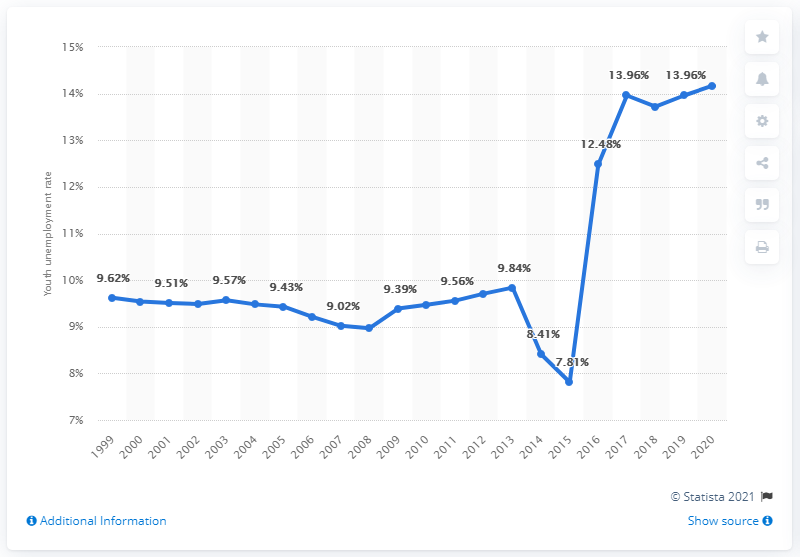Point out several critical features in this image. In 2020, Nigeria's youth unemployment rate was estimated to be 14.17%. 